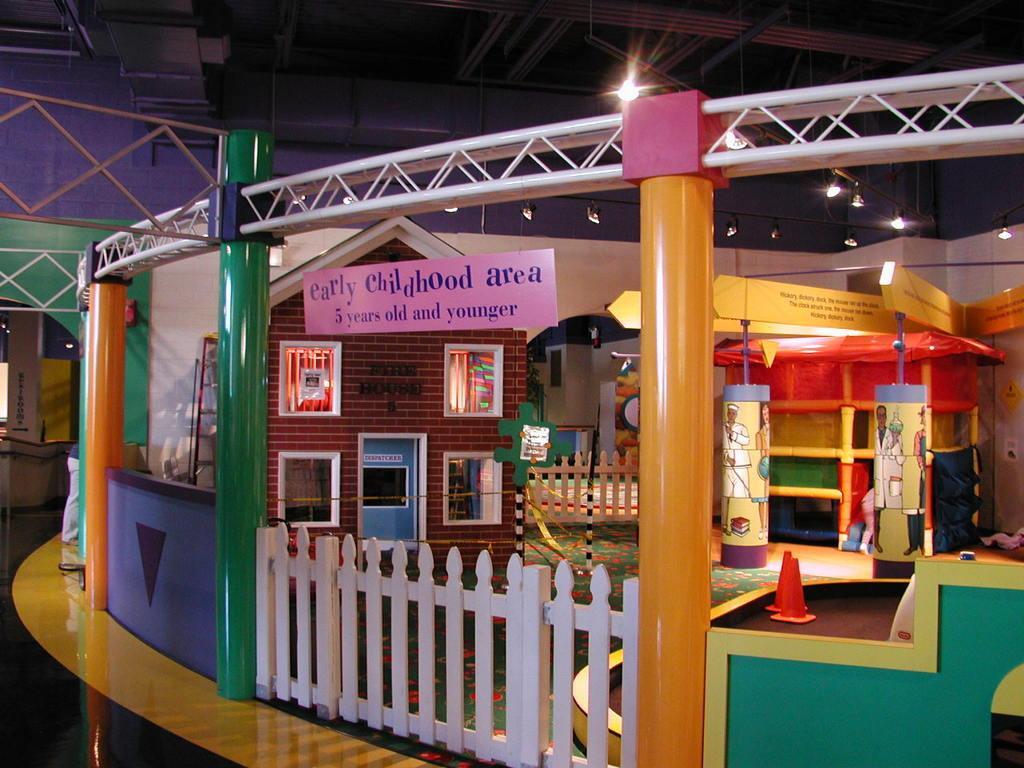How would you summarize this image in a sentence or two? The picture consists of child play area. In this picture there are pillars, gate, frames and other objects. At the top there are lights and ceiling. On the left there is a person and there are pillar, window and a light. 